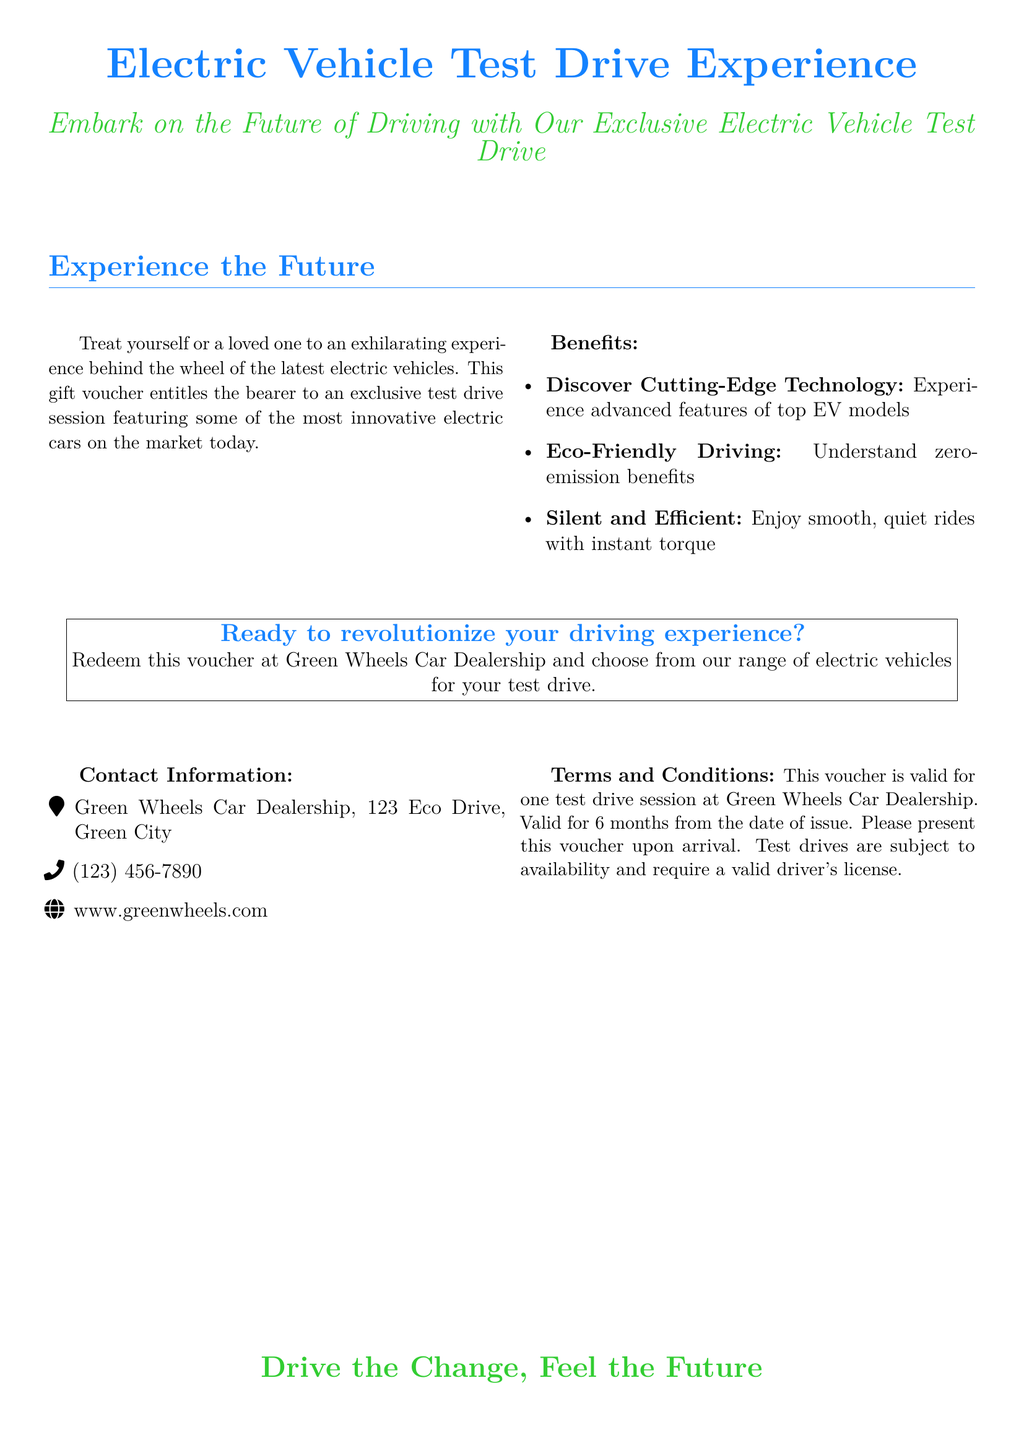What is featured prominently on the voucher? The document describes the gift voucher design, which includes an electric car prominently featured.
Answer: Electric car How long is the voucher valid? The terms state that the voucher is valid for 6 months from the date of issue.
Answer: 6 months What is the name of the dealership? The contact information section provides the name of the dealership, which is mentioned at the top.
Answer: Green Wheels Car Dealership What type of driving experience does the voucher provide? The document specifies what type of experience the voucher offers, which is highlighted in the main text.
Answer: Test drive session What should be presented upon arrival? The terms indicate that the voucher must be presented upon arrival for the test drive.
Answer: This voucher What are recipients encouraged to discover during the test drive? The benefits section invites recipients to understand and experience something specific during the test drive.
Answer: Cutting-Edge Technology What is necessary to participate in the test drive? The terms outline that a valid requirement is needed for participation.
Answer: Valid driver's license Which city is the dealership located in? The contact information section includes the city where the dealership is located.
Answer: Green City What phrase emphasizes the purpose of the voucher? The document concludes with a statement that encapsulates the mission behind the voucher.
Answer: Drive the Change, Feel the Future 